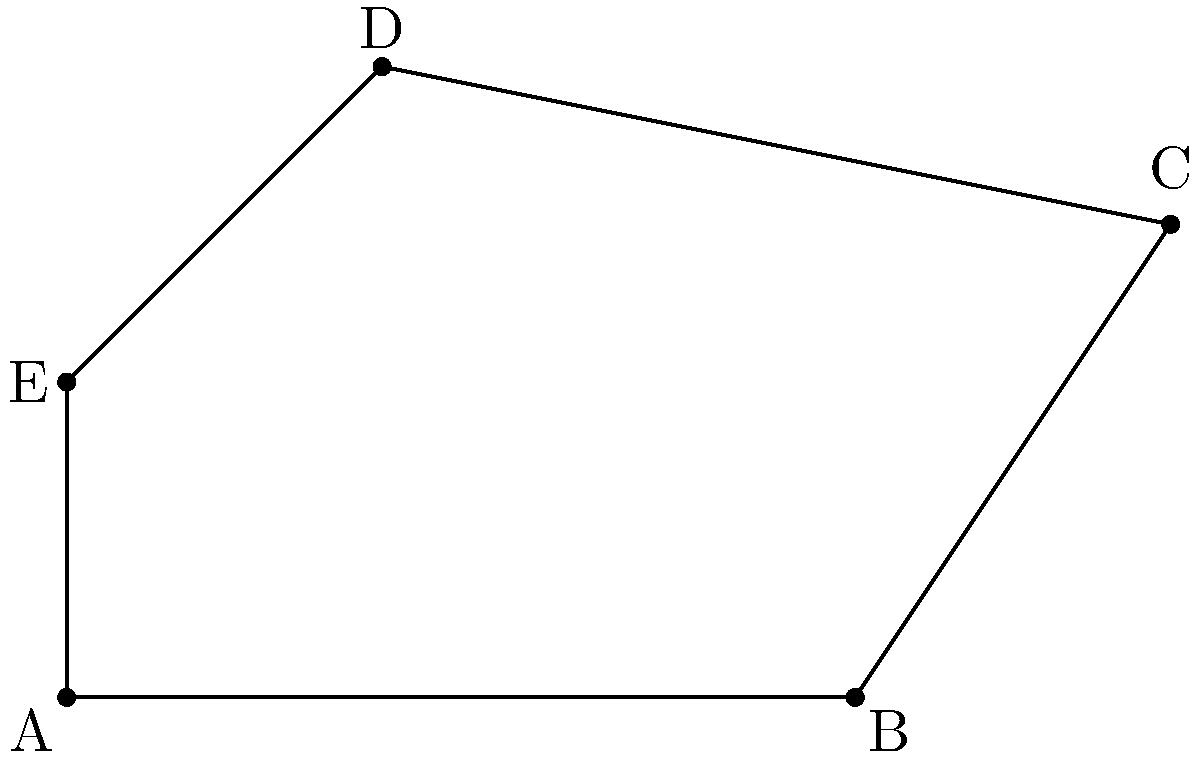As part of your surveillance duties, you've identified an irregular zone of interest represented by the polygon ABCDE in the coordinate plane. Calculate the area of this zone given the following coordinates: A(0,0), B(5,0), C(7,3), D(2,4), and E(0,2). To calculate the area of the irregular polygon ABCDE, we can use the Shoelace formula (also known as the surveyor's formula). This method works for any polygon given its vertices in the coordinate plane.

The steps are as follows:

1) List the coordinates in order, repeating the first coordinate at the end:
   (0,0), (5,0), (7,3), (2,4), (0,2), (0,0)

2) Multiply each x-coordinate by the next y-coordinate and sum the results:
   $S_1 = (0 \cdot 0) + (5 \cdot 3) + (7 \cdot 4) + (2 \cdot 2) + (0 \cdot 0) = 15 + 28 + 4 = 47$

3) Multiply each y-coordinate by the next x-coordinate and sum the results:
   $S_2 = (0 \cdot 5) + (0 \cdot 7) + (3 \cdot 2) + (4 \cdot 0) + (2 \cdot 0) = 6$

4) Subtract $S_2$ from $S_1$:
   $47 - 6 = 41$

5) Divide the result by 2 to get the area:
   Area $= \frac{41}{2} = 20.5$

Therefore, the area of the irregular surveillance zone is 20.5 square units.
Answer: 20.5 square units 